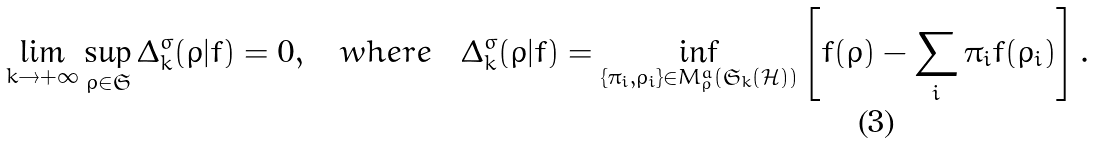Convert formula to latex. <formula><loc_0><loc_0><loc_500><loc_500>\lim _ { k \rightarrow + \infty } \sup _ { \rho \in \mathfrak { S } } \Delta ^ { \sigma } _ { k } ( \rho | f ) = 0 , \quad w h e r e \quad \Delta ^ { \sigma } _ { k } ( \rho | f ) = \inf _ { \{ \pi _ { i } , \rho _ { i } \} \in M ^ { a } _ { \rho } ( \mathfrak { S } _ { k } ( \mathcal { H } ) ) } \left [ f ( \rho ) - \sum _ { i } \pi _ { i } f ( \rho _ { i } ) \right ] .</formula> 